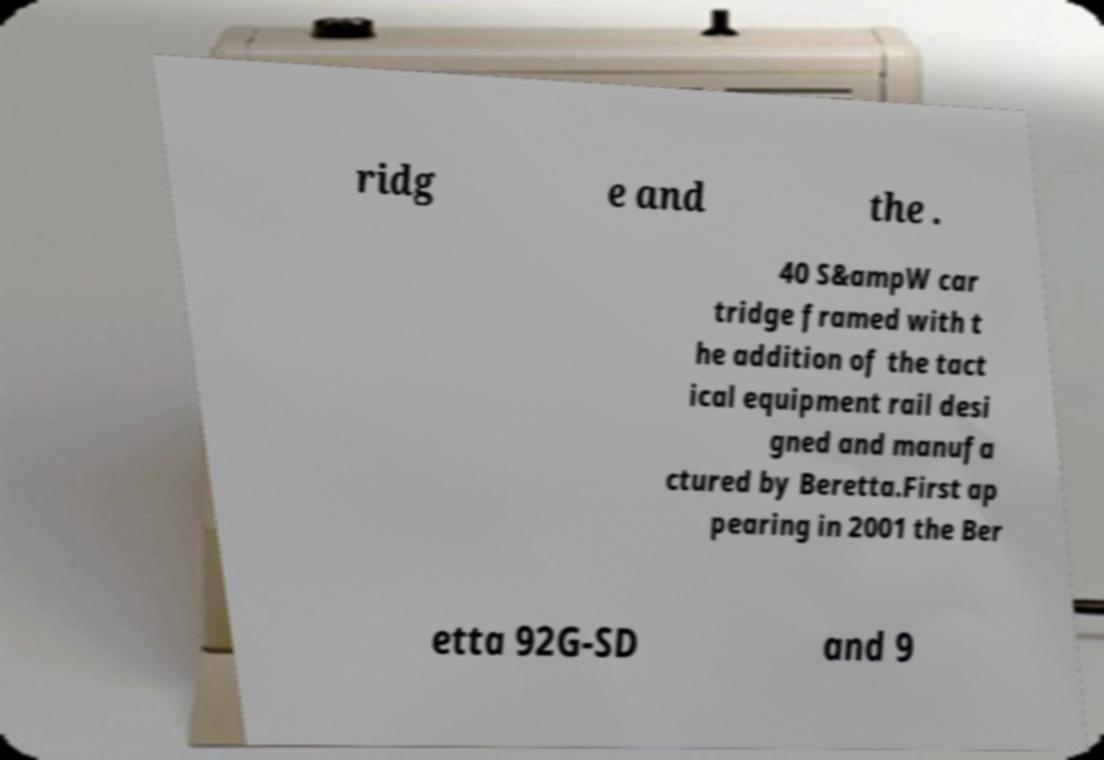For documentation purposes, I need the text within this image transcribed. Could you provide that? ridg e and the . 40 S&ampW car tridge framed with t he addition of the tact ical equipment rail desi gned and manufa ctured by Beretta.First ap pearing in 2001 the Ber etta 92G-SD and 9 